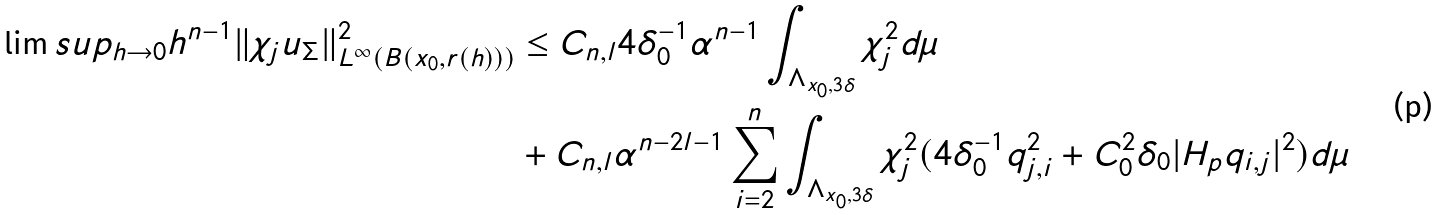Convert formula to latex. <formula><loc_0><loc_0><loc_500><loc_500>\lim s u p _ { h \to 0 } h ^ { n - 1 } \| \chi _ { j } u _ { \Sigma } \| _ { L ^ { \infty } ( B ( x _ { 0 } , r ( h ) ) ) } ^ { 2 } & \leq C _ { n , l } { 4 } \delta _ { 0 } ^ { - 1 } \alpha ^ { n - 1 } \int _ { \Lambda _ { x _ { 0 } , 3 \delta } } \chi _ { j } ^ { 2 } d \mu \\ & + C _ { n , l } \alpha ^ { n - 2 l - 1 } \sum _ { i = 2 } ^ { n } \int _ { \Lambda _ { x _ { 0 } , 3 \delta } } \chi _ { j } ^ { 2 } ( { 4 } \delta _ { 0 } ^ { - 1 } q _ { j , i } ^ { 2 } + { C _ { 0 } ^ { 2 } } \delta _ { 0 } | H _ { p } q _ { i , j } | ^ { 2 } ) d \mu</formula> 